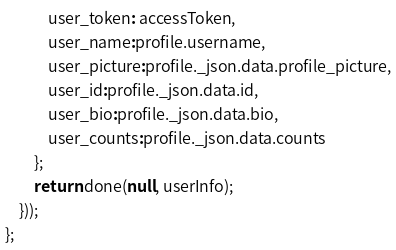<code> <loc_0><loc_0><loc_500><loc_500><_JavaScript_>			user_token: accessToken,
			user_name:profile.username,
			user_picture:profile._json.data.profile_picture,
			user_id:profile._json.data.id,
			user_bio:profile._json.data.bio,
			user_counts:profile._json.data.counts
		};
		return done(null, userInfo);
	}));
};</code> 